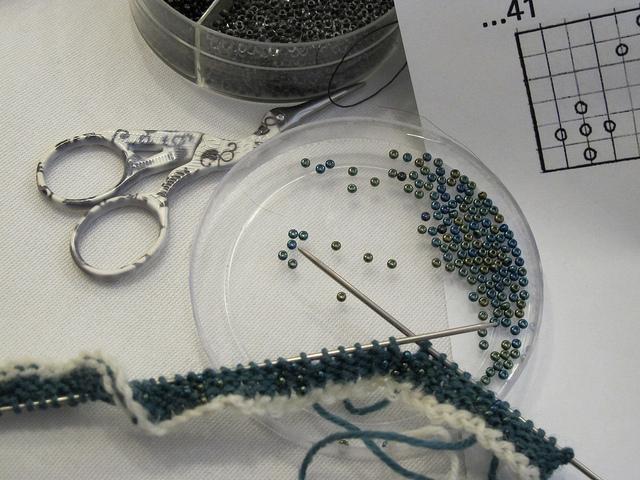How many bowls can be seen?
Give a very brief answer. 1. How many people are holding tennis rackets?
Give a very brief answer. 0. 